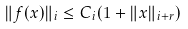Convert formula to latex. <formula><loc_0><loc_0><loc_500><loc_500>\| f ( x ) \| _ { i } \leq C _ { i } ( 1 + \| x \| _ { i + r } )</formula> 